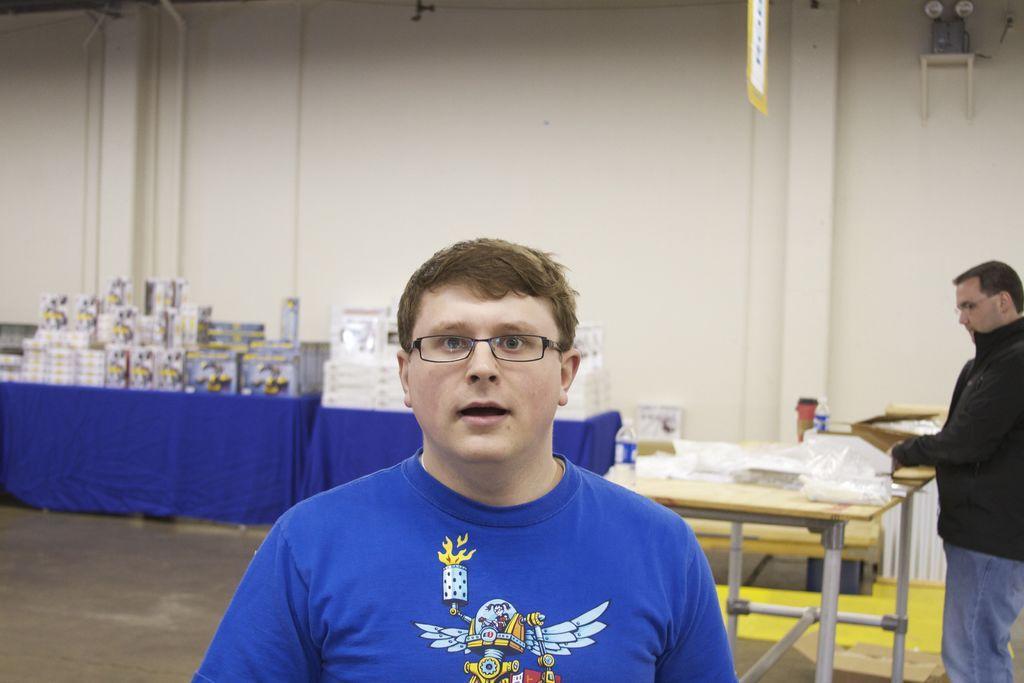Can you describe this image briefly? This picture is of inside. On the right corner there is a man holding a box and standing. In the center there is a man wearing a blue color shirt and seems to be standing. In the background we can see the table, on the top of which boxes are placed. On the right we can see a table, on the top of which Bottles and a cover is placed and there is a wall. 